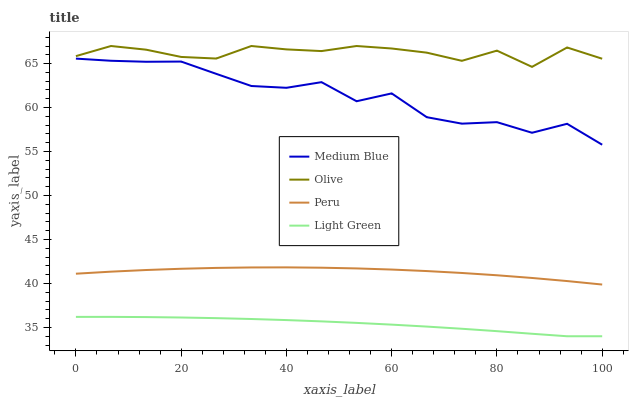Does Medium Blue have the minimum area under the curve?
Answer yes or no. No. Does Medium Blue have the maximum area under the curve?
Answer yes or no. No. Is Medium Blue the smoothest?
Answer yes or no. No. Is Light Green the roughest?
Answer yes or no. No. Does Medium Blue have the lowest value?
Answer yes or no. No. Does Medium Blue have the highest value?
Answer yes or no. No. Is Medium Blue less than Olive?
Answer yes or no. Yes. Is Peru greater than Light Green?
Answer yes or no. Yes. Does Medium Blue intersect Olive?
Answer yes or no. No. 